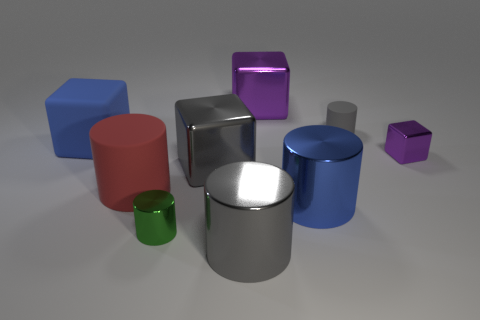What purpose might these objects serve? The objects appear to be basic geometric solids, likely used as 3D models for visualization or educational purposes to study shapes, lighting, and materials in computer graphics. 